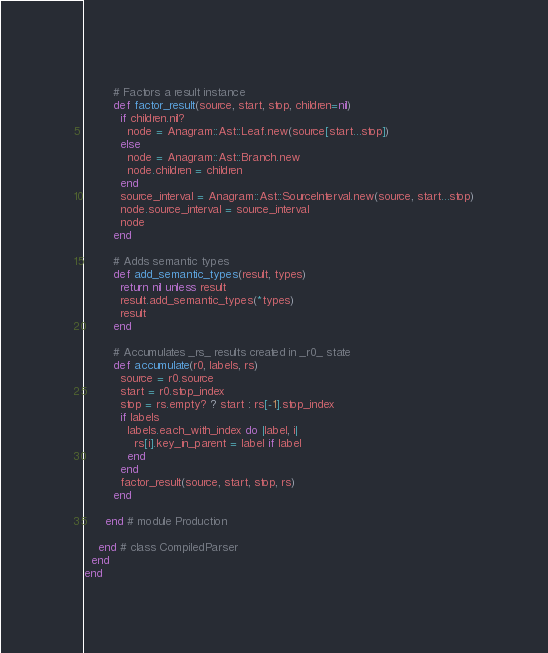<code> <loc_0><loc_0><loc_500><loc_500><_Ruby_>        
        # Factors a result instance
        def factor_result(source, start, stop, children=nil)
          if children.nil?
            node = Anagram::Ast::Leaf.new(source[start...stop])
          else
            node = Anagram::Ast::Branch.new
            node.children = children
          end
          source_interval = Anagram::Ast::SourceInterval.new(source, start...stop)
          node.source_interval = source_interval
          node
        end
    
        # Adds semantic types
        def add_semantic_types(result, types)
          return nil unless result
          result.add_semantic_types(*types)
          result
        end
    
        # Accumulates _rs_ results created in _r0_ state
        def accumulate(r0, labels, rs)
          source = r0.source
          start = r0.stop_index
          stop = rs.empty? ? start : rs[-1].stop_index
          if labels
            labels.each_with_index do |label, i|
              rs[i].key_in_parent = label if label
            end
          end
          factor_result(source, start, stop, rs)
        end
    
      end # module Production
      
    end # class CompiledParser
  end
end</code> 